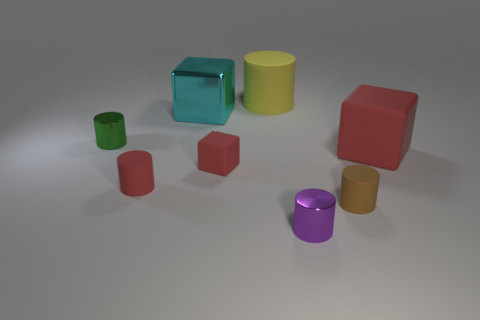Add 2 tiny blue cubes. How many objects exist? 10 Subtract all cubes. How many objects are left? 5 Add 8 large brown blocks. How many large brown blocks exist? 8 Subtract 0 blue cylinders. How many objects are left? 8 Subtract all tiny red cylinders. Subtract all cylinders. How many objects are left? 2 Add 6 purple cylinders. How many purple cylinders are left? 7 